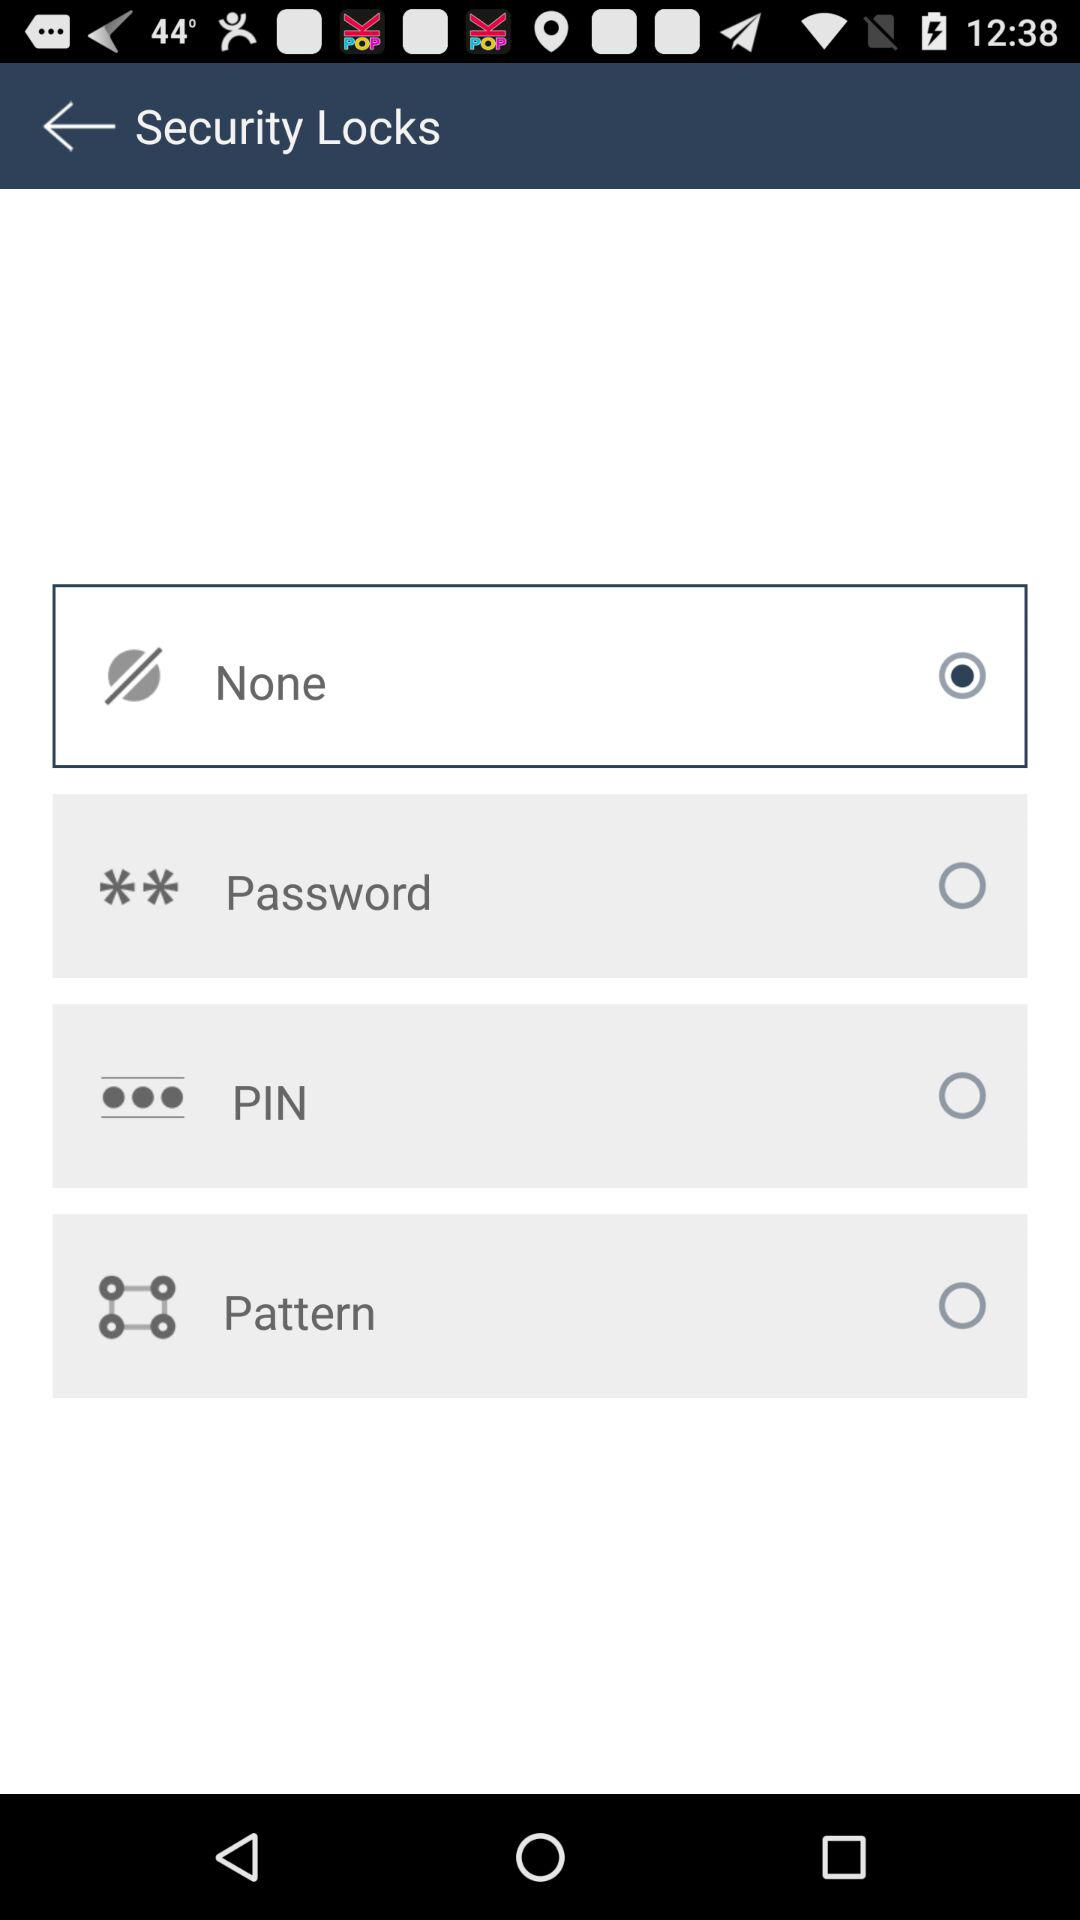What is the pin number?
When the provided information is insufficient, respond with <no answer>. <no answer> 